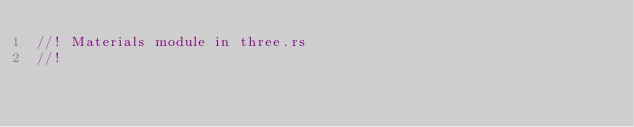Convert code to text. <code><loc_0><loc_0><loc_500><loc_500><_Rust_>//! Materials module in three.rs
//!</code> 